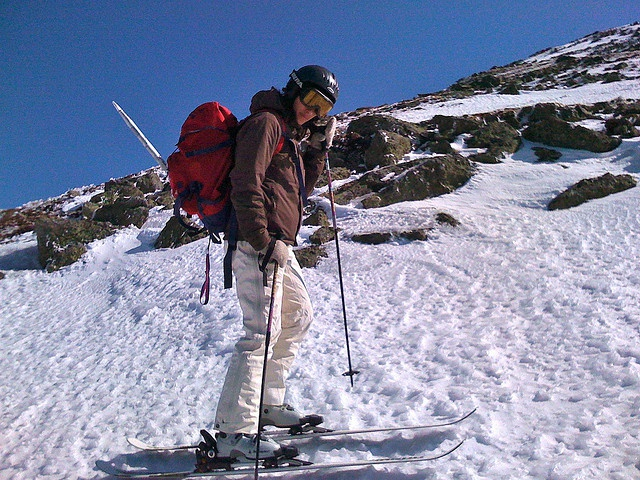Describe the objects in this image and their specific colors. I can see people in blue, black, gray, darkgray, and lightgray tones, backpack in blue, black, maroon, brown, and navy tones, and skis in blue, lavender, gray, and darkgray tones in this image. 